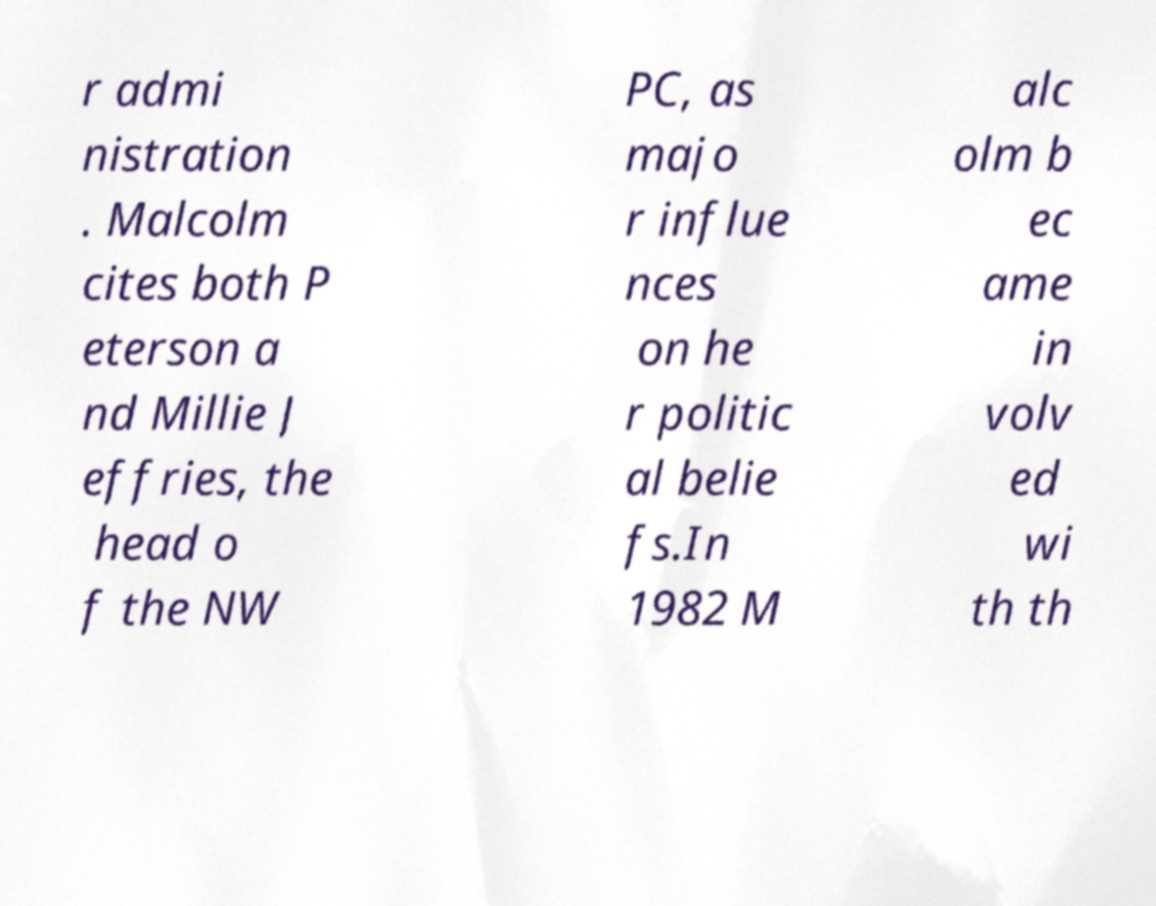For documentation purposes, I need the text within this image transcribed. Could you provide that? r admi nistration . Malcolm cites both P eterson a nd Millie J effries, the head o f the NW PC, as majo r influe nces on he r politic al belie fs.In 1982 M alc olm b ec ame in volv ed wi th th 